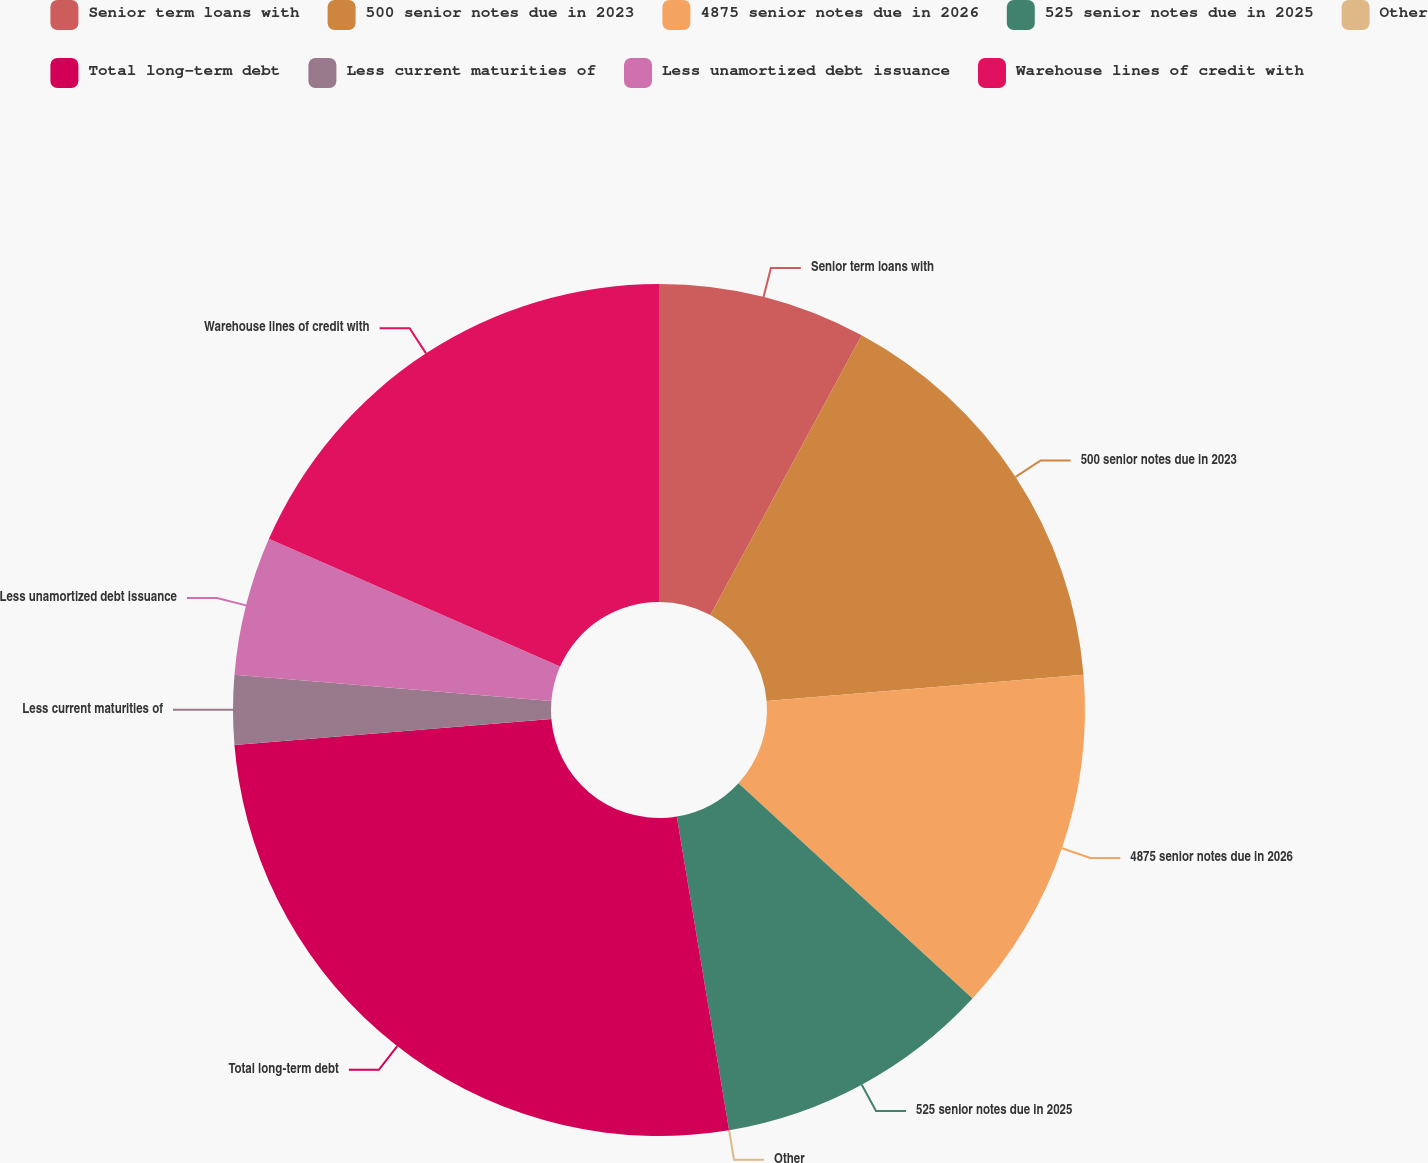Convert chart to OTSL. <chart><loc_0><loc_0><loc_500><loc_500><pie_chart><fcel>Senior term loans with<fcel>500 senior notes due in 2023<fcel>4875 senior notes due in 2026<fcel>525 senior notes due in 2025<fcel>Other<fcel>Total long-term debt<fcel>Less current maturities of<fcel>Less unamortized debt issuance<fcel>Warehouse lines of credit with<nl><fcel>7.89%<fcel>15.79%<fcel>13.16%<fcel>10.53%<fcel>0.0%<fcel>26.32%<fcel>2.63%<fcel>5.26%<fcel>18.42%<nl></chart> 